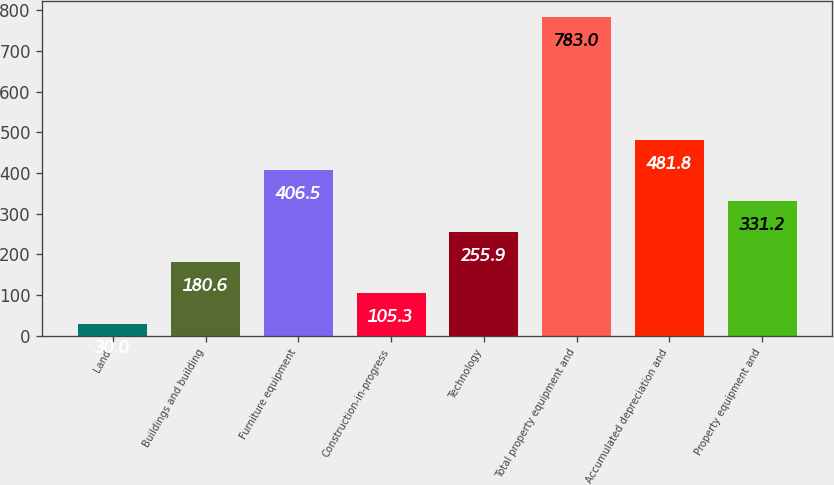Convert chart to OTSL. <chart><loc_0><loc_0><loc_500><loc_500><bar_chart><fcel>Land<fcel>Buildings and building<fcel>Furniture equipment<fcel>Construction-in-progress<fcel>Technology<fcel>Total property equipment and<fcel>Accumulated depreciation and<fcel>Property equipment and<nl><fcel>30<fcel>180.6<fcel>406.5<fcel>105.3<fcel>255.9<fcel>783<fcel>481.8<fcel>331.2<nl></chart> 